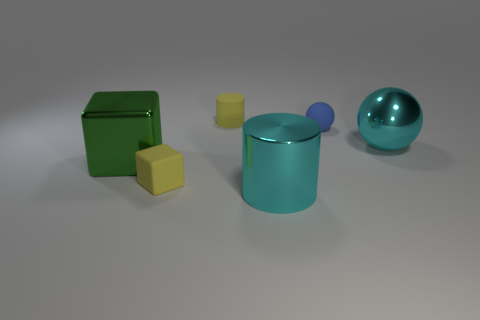There is a object that is on the right side of the green metallic block and on the left side of the tiny cylinder; what shape is it?
Give a very brief answer. Cube. There is a tiny thing that is in front of the tiny blue thing; what is its color?
Your answer should be compact. Yellow. There is a thing that is on the left side of the cyan metal cylinder and behind the green object; what size is it?
Your response must be concise. Small. Does the tiny blue thing have the same material as the cylinder that is behind the big cyan metallic cylinder?
Your response must be concise. Yes. How many other blue rubber things are the same shape as the blue matte object?
Your answer should be compact. 0. There is a cylinder that is the same color as the big metal ball; what is it made of?
Ensure brevity in your answer.  Metal. How many large metal cylinders are there?
Provide a succinct answer. 1. Is the shape of the small blue object the same as the yellow rubber thing left of the tiny matte cylinder?
Make the answer very short. No. What number of things are matte cylinders or metal things that are to the left of the rubber sphere?
Your response must be concise. 3. There is a big cyan thing that is the same shape as the blue rubber object; what material is it?
Offer a very short reply. Metal. 